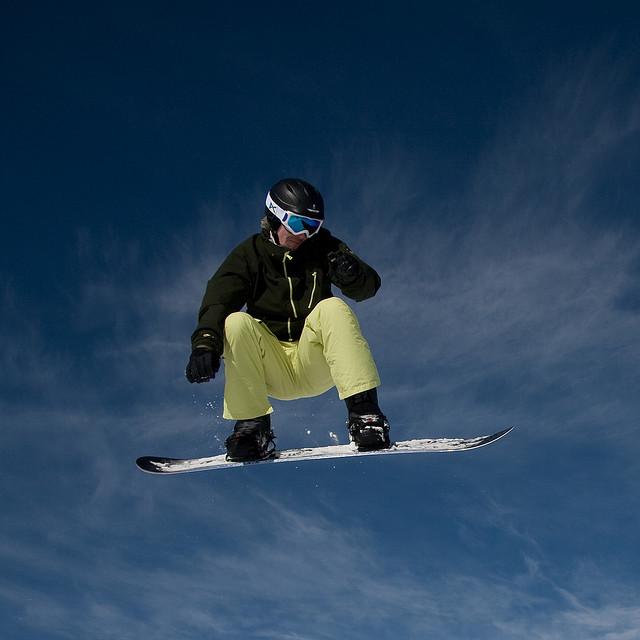Is it raining?
Be succinct. No. What is the guy riding?
Keep it brief. Snowboard. Is the snowboarder in midair?
Quick response, please. Yes. What sport is the guy doing?
Short answer required. Snowboarding. Can you see mountains?
Be succinct. No. What does he wear to protect his eyes?
Give a very brief answer. Goggles. 